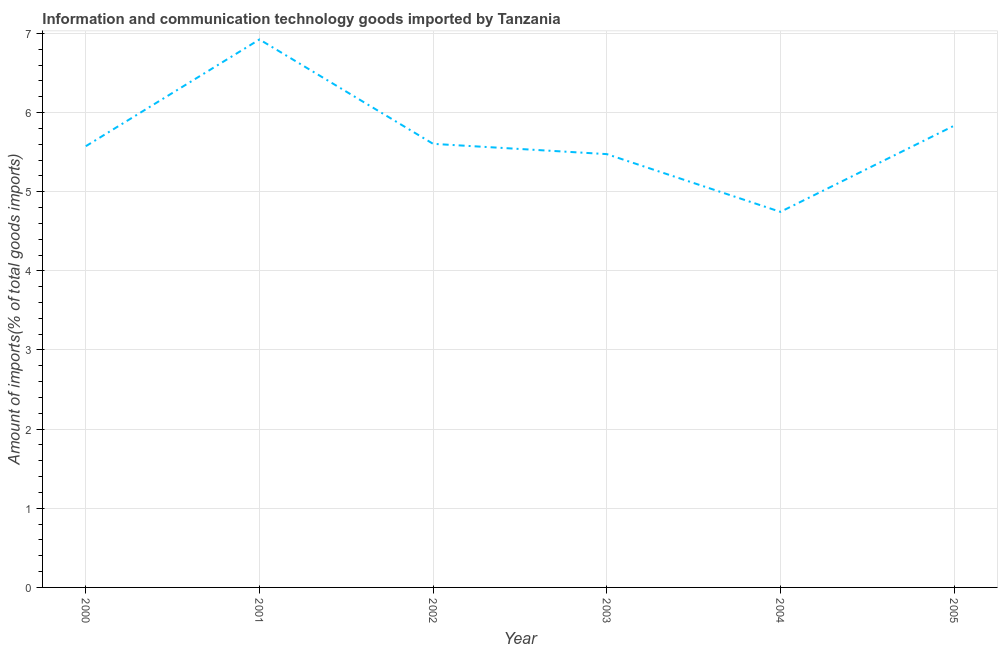What is the amount of ict goods imports in 2003?
Keep it short and to the point. 5.47. Across all years, what is the maximum amount of ict goods imports?
Your answer should be very brief. 6.92. Across all years, what is the minimum amount of ict goods imports?
Offer a terse response. 4.75. In which year was the amount of ict goods imports maximum?
Give a very brief answer. 2001. What is the sum of the amount of ict goods imports?
Provide a short and direct response. 34.16. What is the difference between the amount of ict goods imports in 2002 and 2005?
Your response must be concise. -0.23. What is the average amount of ict goods imports per year?
Give a very brief answer. 5.69. What is the median amount of ict goods imports?
Your response must be concise. 5.59. What is the ratio of the amount of ict goods imports in 2000 to that in 2003?
Your answer should be compact. 1.02. Is the difference between the amount of ict goods imports in 2000 and 2001 greater than the difference between any two years?
Offer a terse response. No. What is the difference between the highest and the second highest amount of ict goods imports?
Offer a terse response. 1.09. Is the sum of the amount of ict goods imports in 2000 and 2002 greater than the maximum amount of ict goods imports across all years?
Make the answer very short. Yes. What is the difference between the highest and the lowest amount of ict goods imports?
Keep it short and to the point. 2.18. In how many years, is the amount of ict goods imports greater than the average amount of ict goods imports taken over all years?
Give a very brief answer. 2. Does the amount of ict goods imports monotonically increase over the years?
Offer a very short reply. No. How many lines are there?
Provide a short and direct response. 1. How many years are there in the graph?
Provide a short and direct response. 6. What is the difference between two consecutive major ticks on the Y-axis?
Keep it short and to the point. 1. Does the graph contain any zero values?
Make the answer very short. No. What is the title of the graph?
Your answer should be very brief. Information and communication technology goods imported by Tanzania. What is the label or title of the Y-axis?
Provide a succinct answer. Amount of imports(% of total goods imports). What is the Amount of imports(% of total goods imports) of 2000?
Ensure brevity in your answer.  5.58. What is the Amount of imports(% of total goods imports) in 2001?
Provide a succinct answer. 6.92. What is the Amount of imports(% of total goods imports) in 2002?
Offer a terse response. 5.6. What is the Amount of imports(% of total goods imports) of 2003?
Your answer should be very brief. 5.47. What is the Amount of imports(% of total goods imports) in 2004?
Offer a very short reply. 4.75. What is the Amount of imports(% of total goods imports) of 2005?
Offer a terse response. 5.83. What is the difference between the Amount of imports(% of total goods imports) in 2000 and 2001?
Your response must be concise. -1.35. What is the difference between the Amount of imports(% of total goods imports) in 2000 and 2002?
Your answer should be very brief. -0.03. What is the difference between the Amount of imports(% of total goods imports) in 2000 and 2003?
Your response must be concise. 0.1. What is the difference between the Amount of imports(% of total goods imports) in 2000 and 2004?
Offer a terse response. 0.83. What is the difference between the Amount of imports(% of total goods imports) in 2000 and 2005?
Provide a short and direct response. -0.26. What is the difference between the Amount of imports(% of total goods imports) in 2001 and 2002?
Your response must be concise. 1.32. What is the difference between the Amount of imports(% of total goods imports) in 2001 and 2003?
Give a very brief answer. 1.45. What is the difference between the Amount of imports(% of total goods imports) in 2001 and 2004?
Provide a short and direct response. 2.18. What is the difference between the Amount of imports(% of total goods imports) in 2001 and 2005?
Your answer should be compact. 1.09. What is the difference between the Amount of imports(% of total goods imports) in 2002 and 2003?
Provide a short and direct response. 0.13. What is the difference between the Amount of imports(% of total goods imports) in 2002 and 2004?
Your answer should be compact. 0.86. What is the difference between the Amount of imports(% of total goods imports) in 2002 and 2005?
Provide a succinct answer. -0.23. What is the difference between the Amount of imports(% of total goods imports) in 2003 and 2004?
Provide a succinct answer. 0.73. What is the difference between the Amount of imports(% of total goods imports) in 2003 and 2005?
Your answer should be compact. -0.36. What is the difference between the Amount of imports(% of total goods imports) in 2004 and 2005?
Offer a very short reply. -1.09. What is the ratio of the Amount of imports(% of total goods imports) in 2000 to that in 2001?
Provide a succinct answer. 0.81. What is the ratio of the Amount of imports(% of total goods imports) in 2000 to that in 2003?
Your response must be concise. 1.02. What is the ratio of the Amount of imports(% of total goods imports) in 2000 to that in 2004?
Make the answer very short. 1.18. What is the ratio of the Amount of imports(% of total goods imports) in 2000 to that in 2005?
Your answer should be compact. 0.96. What is the ratio of the Amount of imports(% of total goods imports) in 2001 to that in 2002?
Provide a succinct answer. 1.24. What is the ratio of the Amount of imports(% of total goods imports) in 2001 to that in 2003?
Provide a succinct answer. 1.26. What is the ratio of the Amount of imports(% of total goods imports) in 2001 to that in 2004?
Your response must be concise. 1.46. What is the ratio of the Amount of imports(% of total goods imports) in 2001 to that in 2005?
Provide a short and direct response. 1.19. What is the ratio of the Amount of imports(% of total goods imports) in 2002 to that in 2003?
Your answer should be very brief. 1.02. What is the ratio of the Amount of imports(% of total goods imports) in 2002 to that in 2004?
Your answer should be very brief. 1.18. What is the ratio of the Amount of imports(% of total goods imports) in 2003 to that in 2004?
Keep it short and to the point. 1.15. What is the ratio of the Amount of imports(% of total goods imports) in 2003 to that in 2005?
Provide a succinct answer. 0.94. What is the ratio of the Amount of imports(% of total goods imports) in 2004 to that in 2005?
Give a very brief answer. 0.81. 